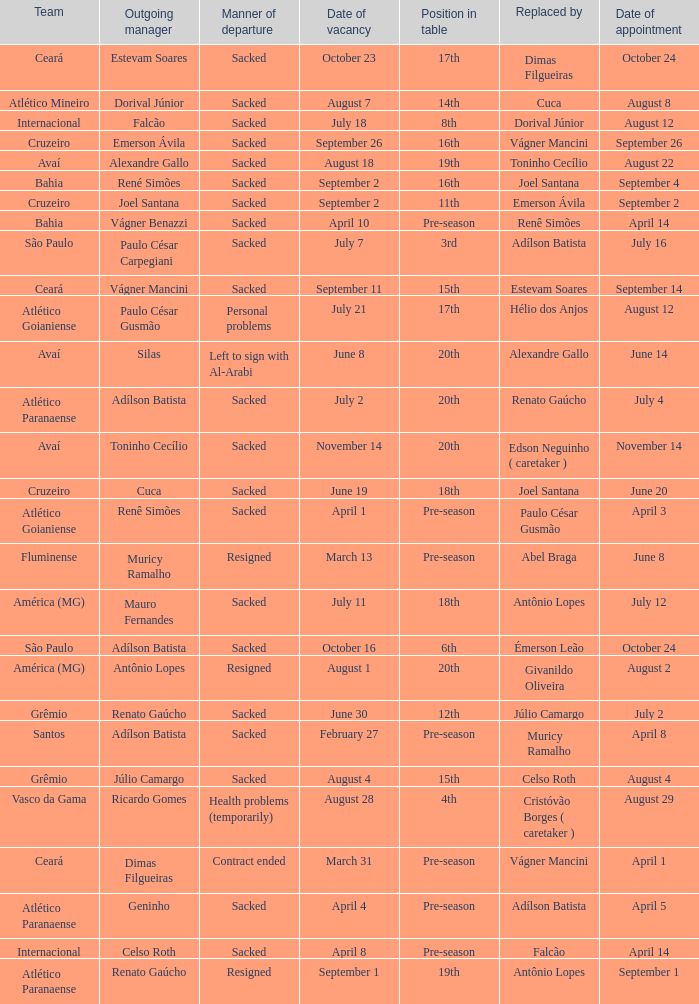How many times did Silas leave as a team manager? 1.0. 